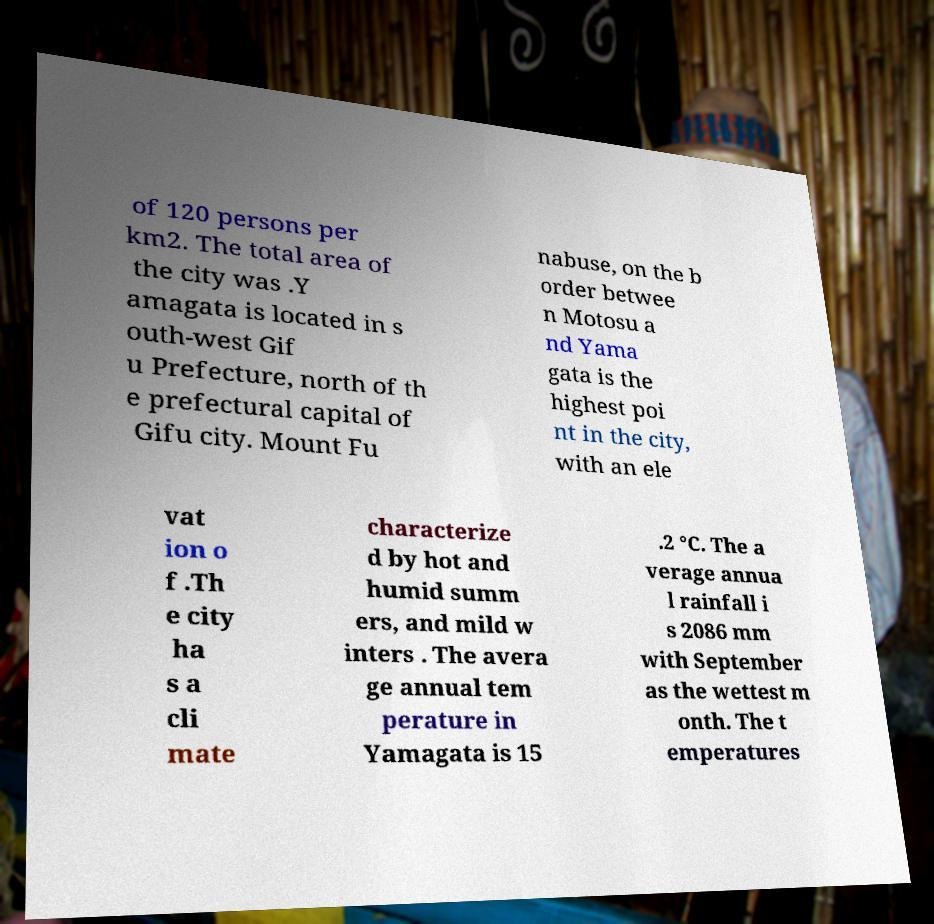Can you read and provide the text displayed in the image?This photo seems to have some interesting text. Can you extract and type it out for me? of 120 persons per km2. The total area of the city was .Y amagata is located in s outh-west Gif u Prefecture, north of th e prefectural capital of Gifu city. Mount Fu nabuse, on the b order betwee n Motosu a nd Yama gata is the highest poi nt in the city, with an ele vat ion o f .Th e city ha s a cli mate characterize d by hot and humid summ ers, and mild w inters . The avera ge annual tem perature in Yamagata is 15 .2 °C. The a verage annua l rainfall i s 2086 mm with September as the wettest m onth. The t emperatures 